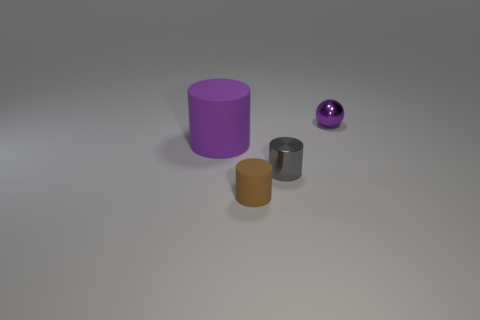What number of other tiny cylinders have the same material as the purple cylinder?
Ensure brevity in your answer.  1. How many gray things are to the right of the rubber cylinder left of the small brown rubber thing?
Your answer should be very brief. 1. Are there any tiny things in front of the small metal sphere?
Make the answer very short. Yes. Is the shape of the rubber thing that is behind the small gray object the same as  the small brown rubber object?
Your answer should be compact. Yes. What is the material of the small ball that is the same color as the big cylinder?
Your answer should be very brief. Metal. What number of spheres are the same color as the big thing?
Keep it short and to the point. 1. The thing to the left of the rubber object that is in front of the gray cylinder is what shape?
Provide a succinct answer. Cylinder. Is there a big brown object that has the same shape as the purple rubber thing?
Keep it short and to the point. No. Does the tiny metal sphere have the same color as the matte object behind the tiny metal cylinder?
Offer a very short reply. Yes. What is the size of the metal ball that is the same color as the big rubber cylinder?
Keep it short and to the point. Small. 